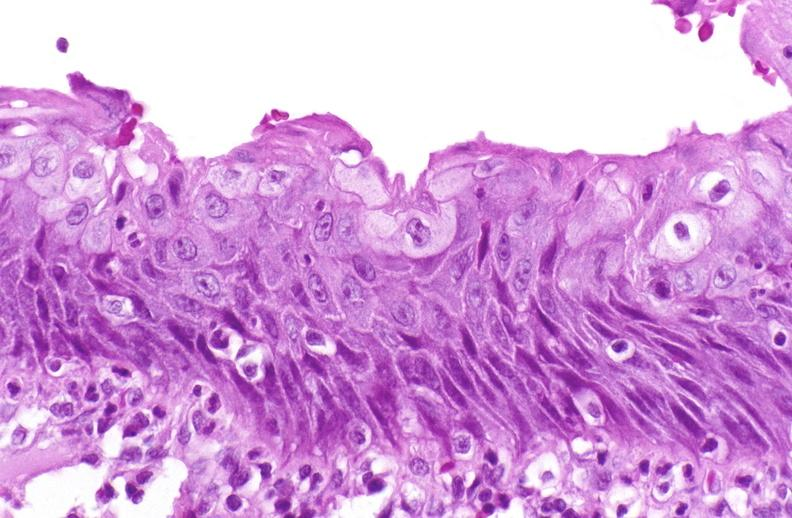does transplant acute rejection show squamous metaplasia, renal pelvis due to nephrolithiasis?
Answer the question using a single word or phrase. No 